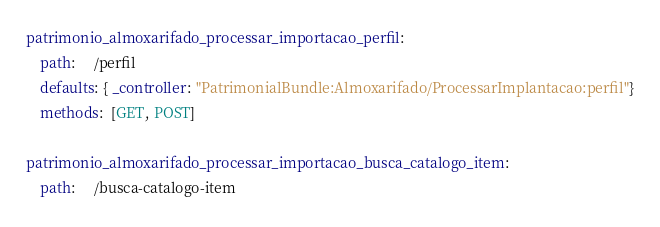Convert code to text. <code><loc_0><loc_0><loc_500><loc_500><_YAML_>patrimonio_almoxarifado_processar_importacao_perfil:
    path:     /perfil
    defaults: { _controller: "PatrimonialBundle:Almoxarifado/ProcessarImplantacao:perfil"}
    methods:  [GET, POST]

patrimonio_almoxarifado_processar_importacao_busca_catalogo_item:
    path:     /busca-catalogo-item</code> 